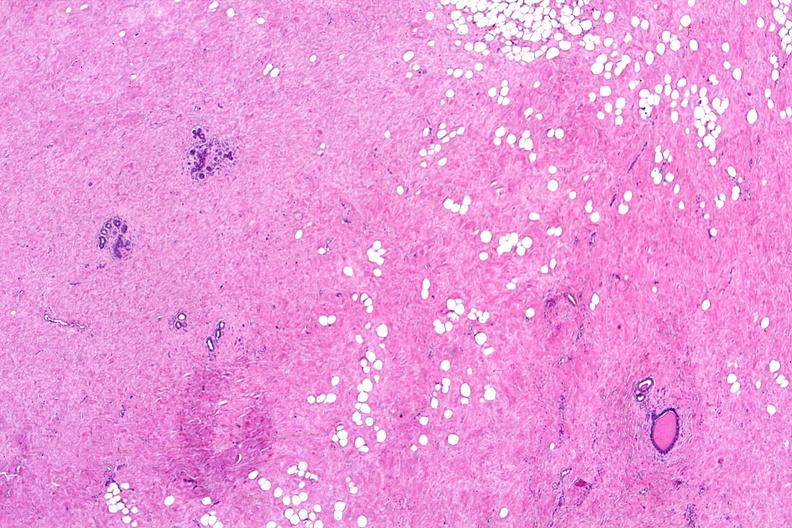where is this from?
Answer the question using a single word or phrase. Female reproductive system 